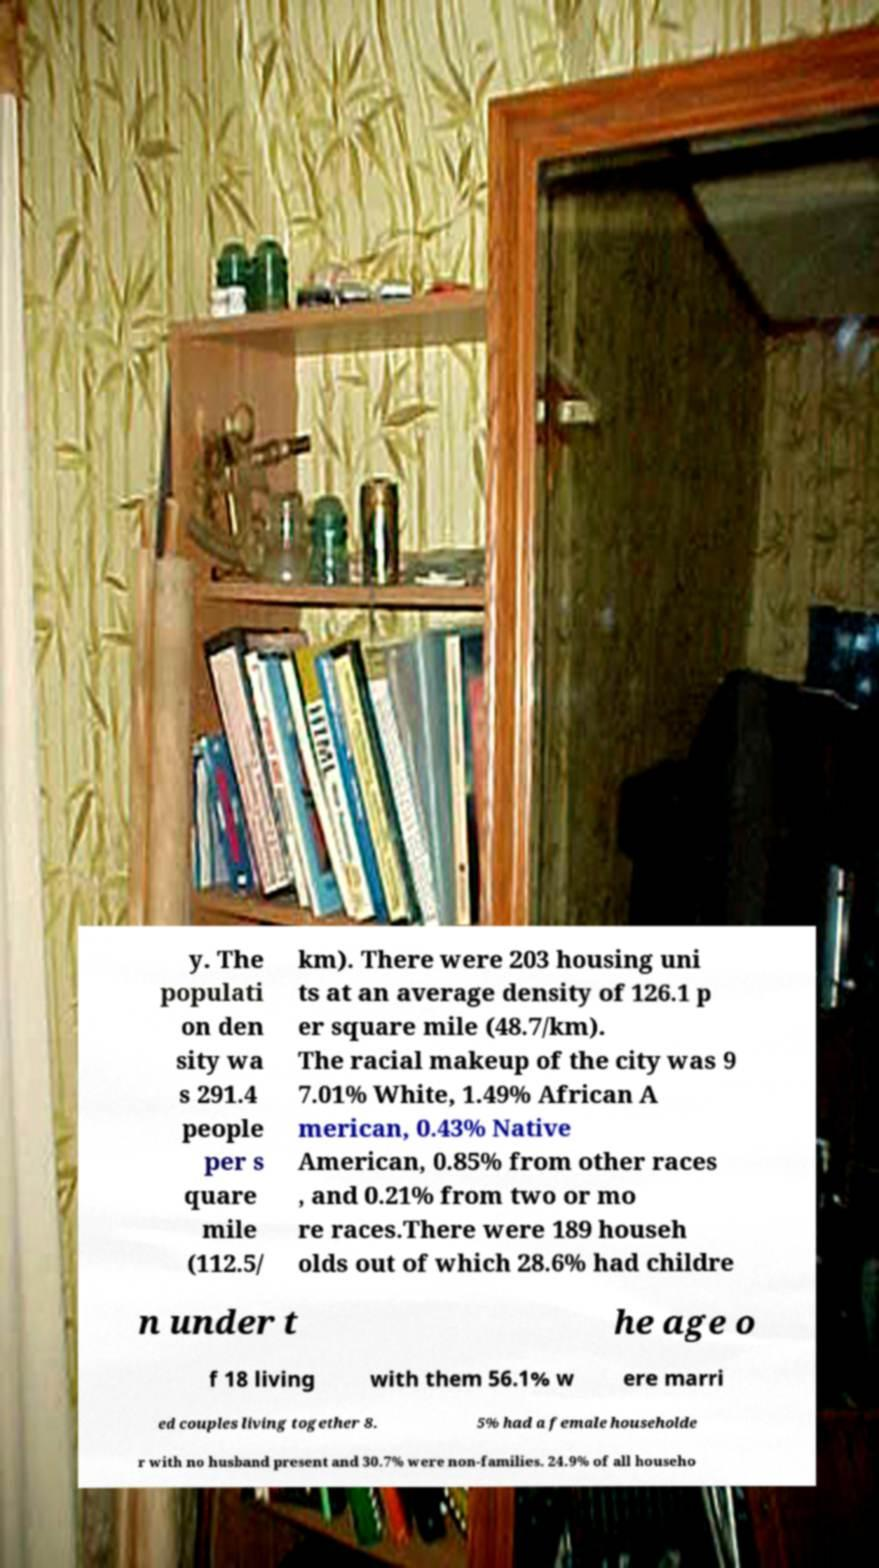For documentation purposes, I need the text within this image transcribed. Could you provide that? y. The populati on den sity wa s 291.4 people per s quare mile (112.5/ km). There were 203 housing uni ts at an average density of 126.1 p er square mile (48.7/km). The racial makeup of the city was 9 7.01% White, 1.49% African A merican, 0.43% Native American, 0.85% from other races , and 0.21% from two or mo re races.There were 189 househ olds out of which 28.6% had childre n under t he age o f 18 living with them 56.1% w ere marri ed couples living together 8. 5% had a female householde r with no husband present and 30.7% were non-families. 24.9% of all househo 